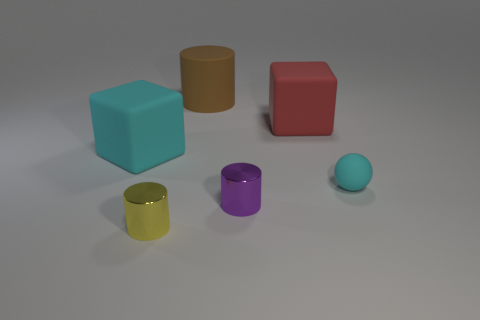What is the material of the big block on the right side of the yellow thing?
Your answer should be compact. Rubber. Are there an equal number of matte balls behind the large red rubber block and blue matte cylinders?
Ensure brevity in your answer.  Yes. What number of other spheres are the same color as the rubber sphere?
Your answer should be compact. 0. There is another rubber object that is the same shape as the large cyan matte thing; what is its color?
Keep it short and to the point. Red. Do the brown matte object and the cyan matte sphere have the same size?
Your answer should be compact. No. Are there an equal number of rubber cylinders that are right of the large cyan block and cylinders behind the red object?
Keep it short and to the point. Yes. Are there any big cyan rubber cylinders?
Your answer should be compact. No. What is the size of the brown thing that is the same shape as the small purple thing?
Give a very brief answer. Large. There is a metal cylinder left of the big brown rubber object; what is its size?
Your answer should be very brief. Small. Is the number of yellow shiny objects that are to the left of the small purple object greater than the number of small red metallic spheres?
Ensure brevity in your answer.  Yes. 